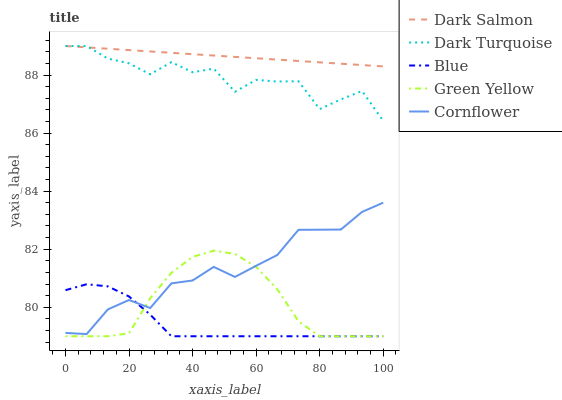Does Blue have the minimum area under the curve?
Answer yes or no. Yes. Does Dark Salmon have the maximum area under the curve?
Answer yes or no. Yes. Does Dark Turquoise have the minimum area under the curve?
Answer yes or no. No. Does Dark Turquoise have the maximum area under the curve?
Answer yes or no. No. Is Dark Salmon the smoothest?
Answer yes or no. Yes. Is Dark Turquoise the roughest?
Answer yes or no. Yes. Is Green Yellow the smoothest?
Answer yes or no. No. Is Green Yellow the roughest?
Answer yes or no. No. Does Dark Turquoise have the lowest value?
Answer yes or no. No. Does Dark Salmon have the highest value?
Answer yes or no. Yes. Does Green Yellow have the highest value?
Answer yes or no. No. Is Green Yellow less than Dark Salmon?
Answer yes or no. Yes. Is Dark Salmon greater than Green Yellow?
Answer yes or no. Yes. Does Dark Turquoise intersect Dark Salmon?
Answer yes or no. Yes. Is Dark Turquoise less than Dark Salmon?
Answer yes or no. No. Is Dark Turquoise greater than Dark Salmon?
Answer yes or no. No. Does Green Yellow intersect Dark Salmon?
Answer yes or no. No. 